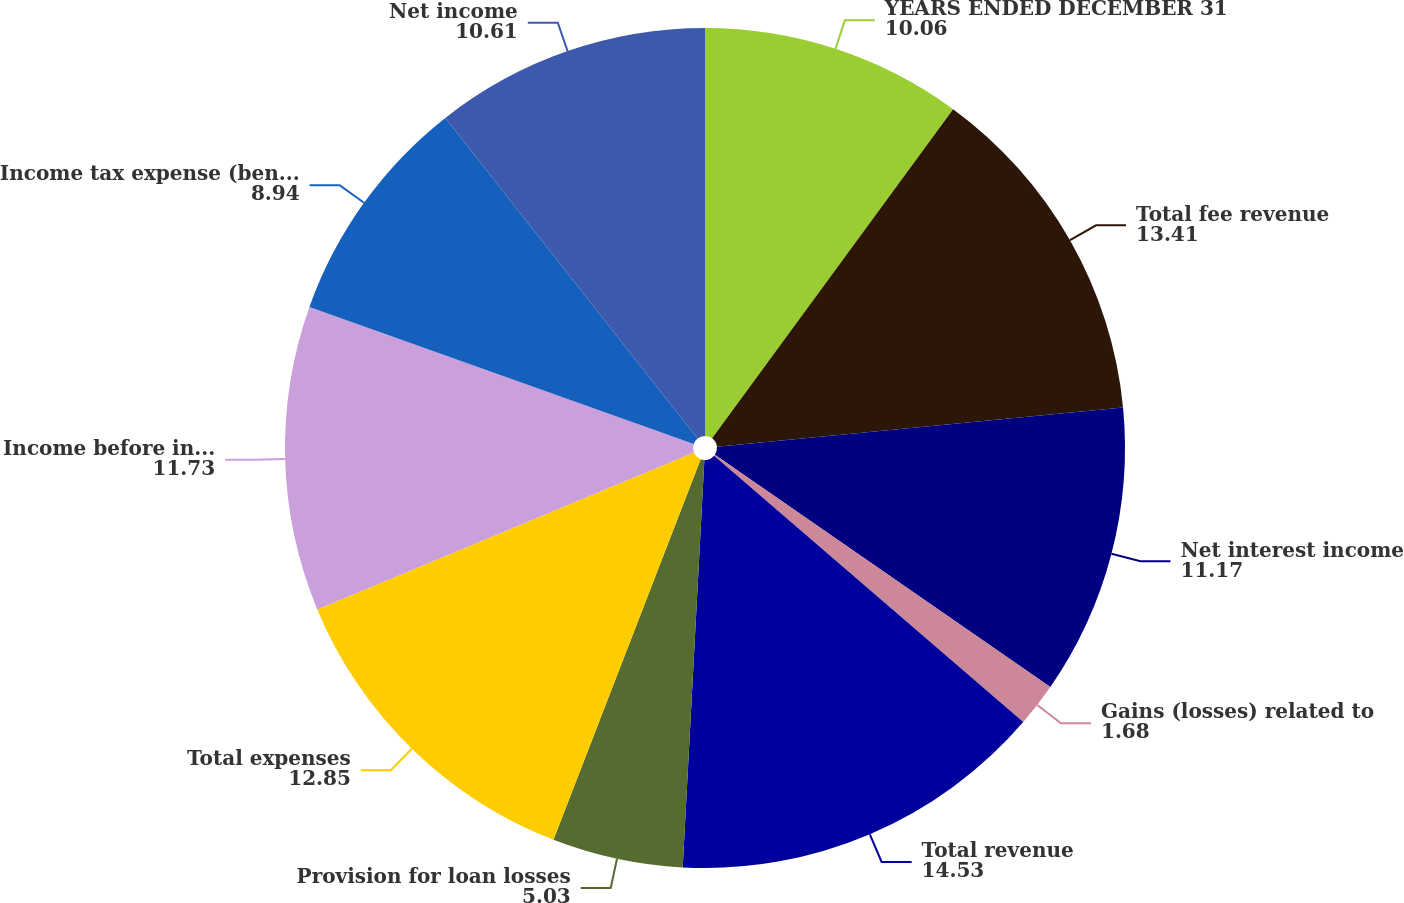Convert chart. <chart><loc_0><loc_0><loc_500><loc_500><pie_chart><fcel>YEARS ENDED DECEMBER 31<fcel>Total fee revenue<fcel>Net interest income<fcel>Gains (losses) related to<fcel>Total revenue<fcel>Provision for loan losses<fcel>Total expenses<fcel>Income before income tax<fcel>Income tax expense (benefit)<fcel>Net income<nl><fcel>10.06%<fcel>13.41%<fcel>11.17%<fcel>1.68%<fcel>14.53%<fcel>5.03%<fcel>12.85%<fcel>11.73%<fcel>8.94%<fcel>10.61%<nl></chart> 